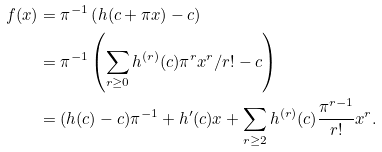Convert formula to latex. <formula><loc_0><loc_0><loc_500><loc_500>f ( x ) & = \pi ^ { - 1 } \left ( h ( c + \pi x ) - c \right ) \\ & = \pi ^ { - 1 } \left ( \sum _ { r \geq 0 } h ^ { ( r ) } ( c ) \pi ^ { r } x ^ { r } / r ! - c \right ) \\ & = ( h ( c ) - c ) \pi ^ { - 1 } + h ^ { \prime } ( c ) x + \sum _ { r \geq 2 } h ^ { ( r ) } ( c ) \frac { \pi ^ { r - 1 } } { r ! } x ^ { r } .</formula> 